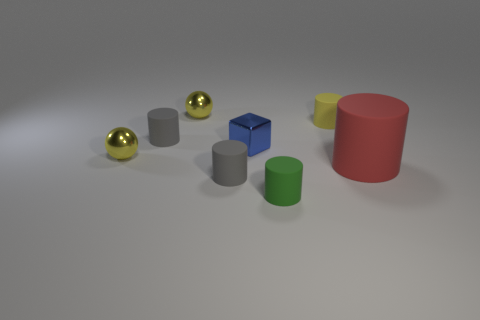What can you infer about the material of the objects? From the image, it seems that the cylinders and cube are made of a matte material which does not reflect much light, indicating they could be plastic or coated metal. The spheres have a polished, reflective surface, suggesting they might be made of polished metal or glass. 